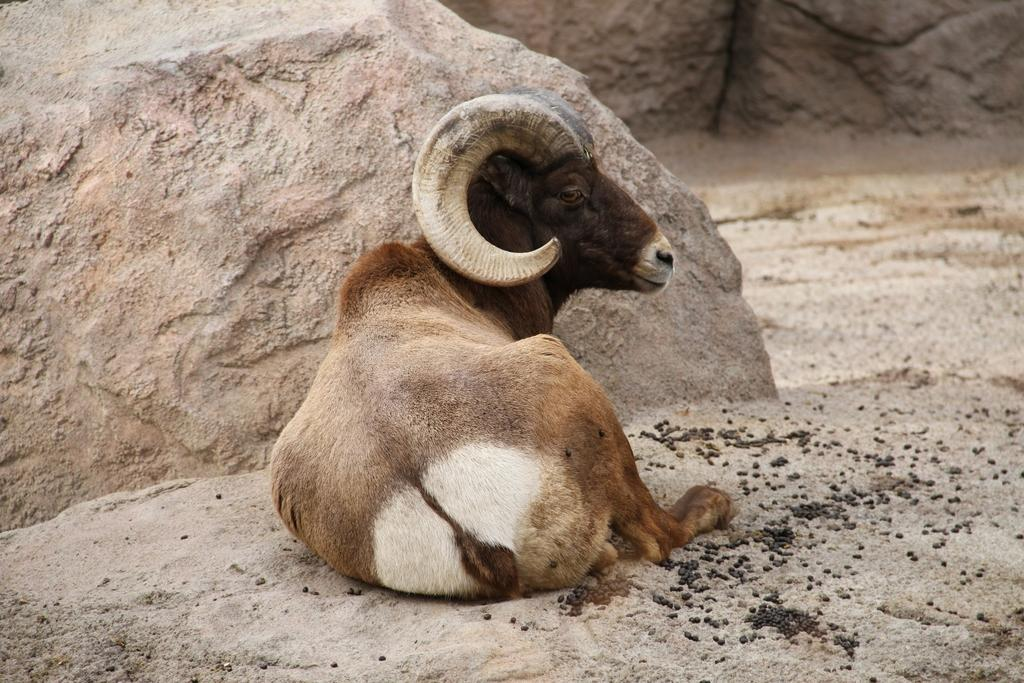What animal is present in the image? There is a goat in the image. What is the goat doing in the image? The goat is sitting on the ground. What can be seen in the background of the image? There are rocks in the background of the image. Are there any fairies flying around the goat in the image? There are no fairies present in the image. What type of spark can be seen coming from the goat's mouth in the image? There is no spark coming from the goat's mouth in the image. 